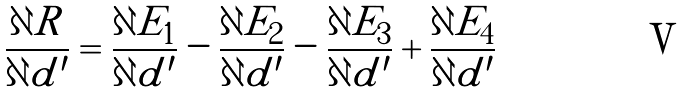<formula> <loc_0><loc_0><loc_500><loc_500>\frac { \partial R } { \partial d ^ { \prime } } = \frac { \partial E _ { 1 } } { \partial d ^ { \prime } } - \frac { \partial E _ { 2 } } { \partial d ^ { \prime } } - \frac { \partial E _ { 3 } } { \partial d ^ { \prime } } + \frac { \partial E _ { 4 } } { \partial d ^ { \prime } }</formula> 